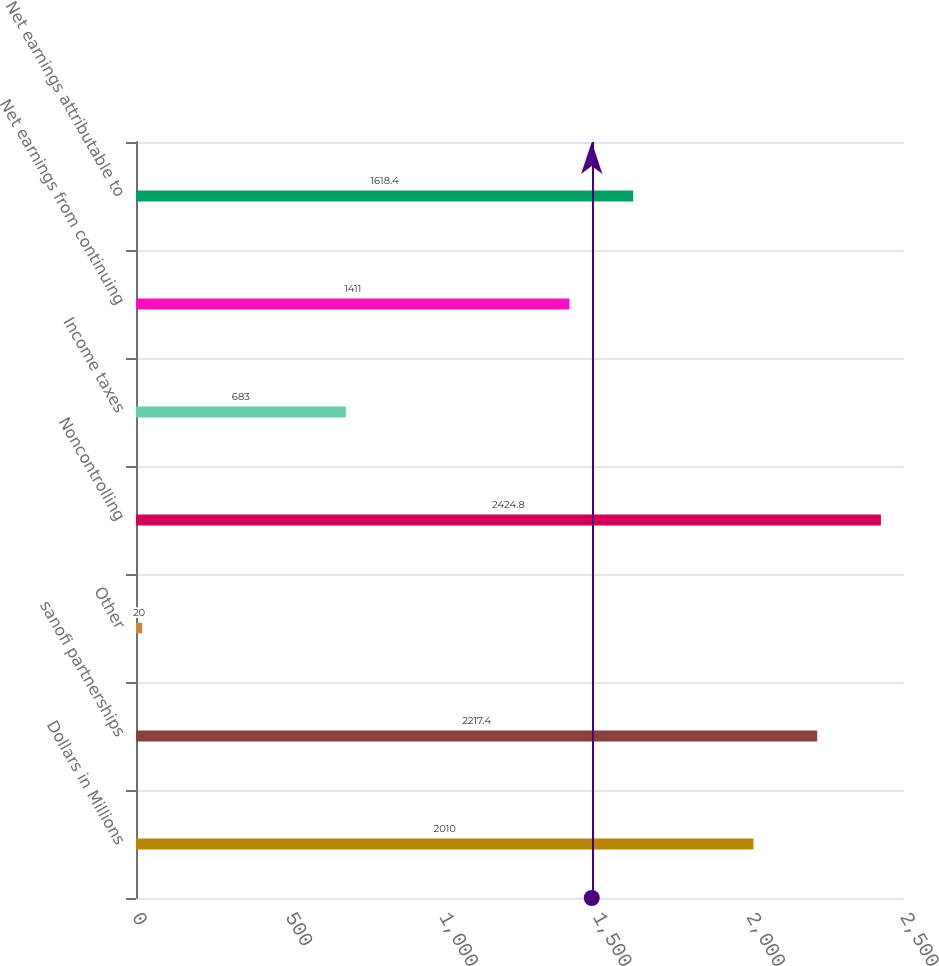Convert chart to OTSL. <chart><loc_0><loc_0><loc_500><loc_500><bar_chart><fcel>Dollars in Millions<fcel>sanofi partnerships<fcel>Other<fcel>Noncontrolling<fcel>Income taxes<fcel>Net earnings from continuing<fcel>Net earnings attributable to<nl><fcel>2010<fcel>2217.4<fcel>20<fcel>2424.8<fcel>683<fcel>1411<fcel>1618.4<nl></chart> 